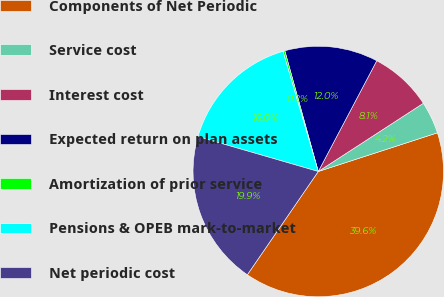Convert chart to OTSL. <chart><loc_0><loc_0><loc_500><loc_500><pie_chart><fcel>Components of Net Periodic<fcel>Service cost<fcel>Interest cost<fcel>Expected return on plan assets<fcel>Amortization of prior service<fcel>Pensions & OPEB mark-to-market<fcel>Net periodic cost<nl><fcel>39.58%<fcel>4.17%<fcel>8.1%<fcel>12.04%<fcel>0.24%<fcel>15.97%<fcel>19.91%<nl></chart> 